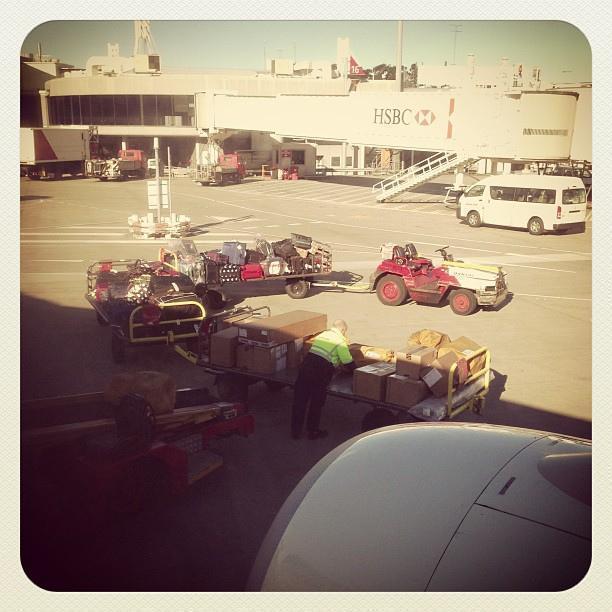What is the big item in the far back right?
Choose the right answer from the provided options to respond to the question.
Options: Baseball stadium, statue, elephant, van. Van. 